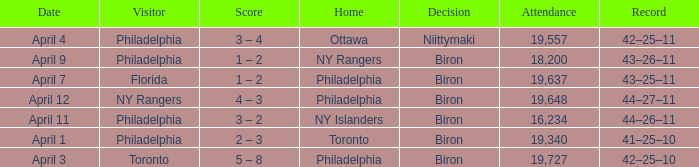Who were the visitors when the home team were the ny rangers? Philadelphia. 